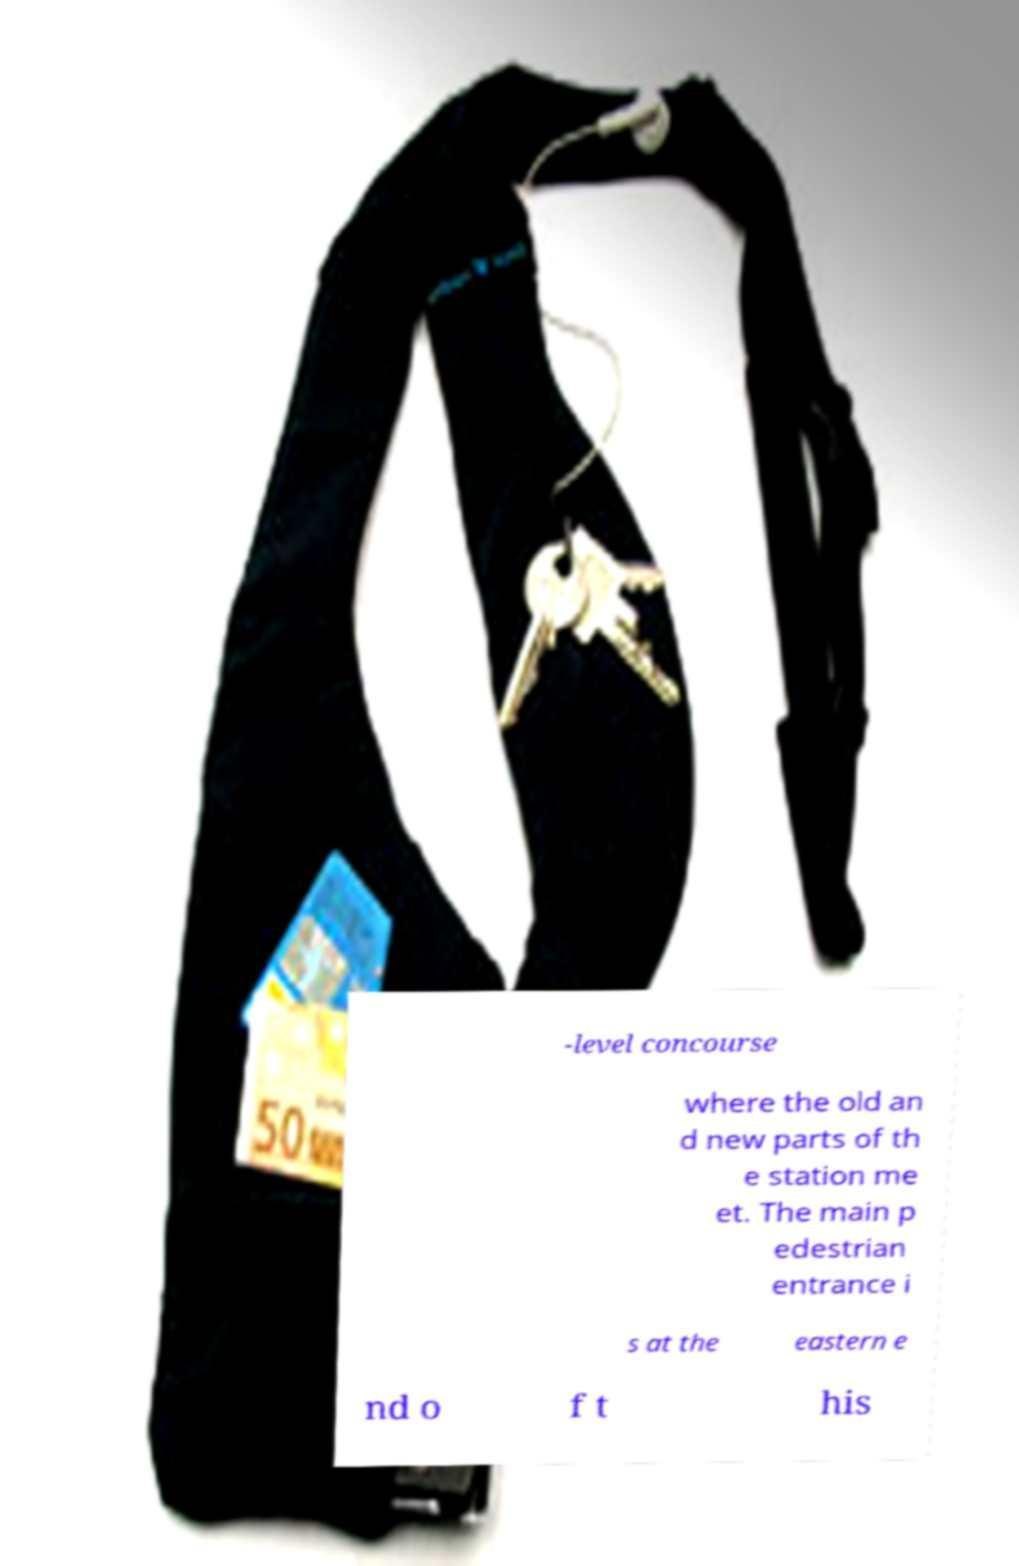What messages or text are displayed in this image? I need them in a readable, typed format. -level concourse where the old an d new parts of th e station me et. The main p edestrian entrance i s at the eastern e nd o f t his 